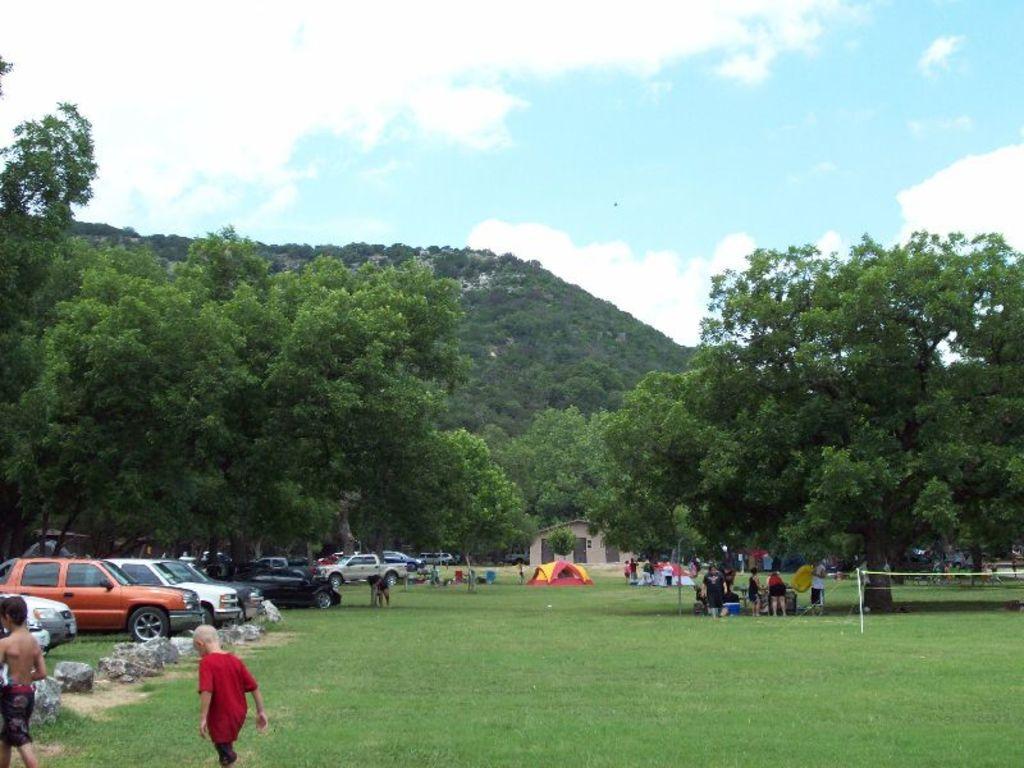Describe this image in one or two sentences. As we can see in the image there is grass, cars, few people here and there, house and trees. On the top there is sky and clouds. 